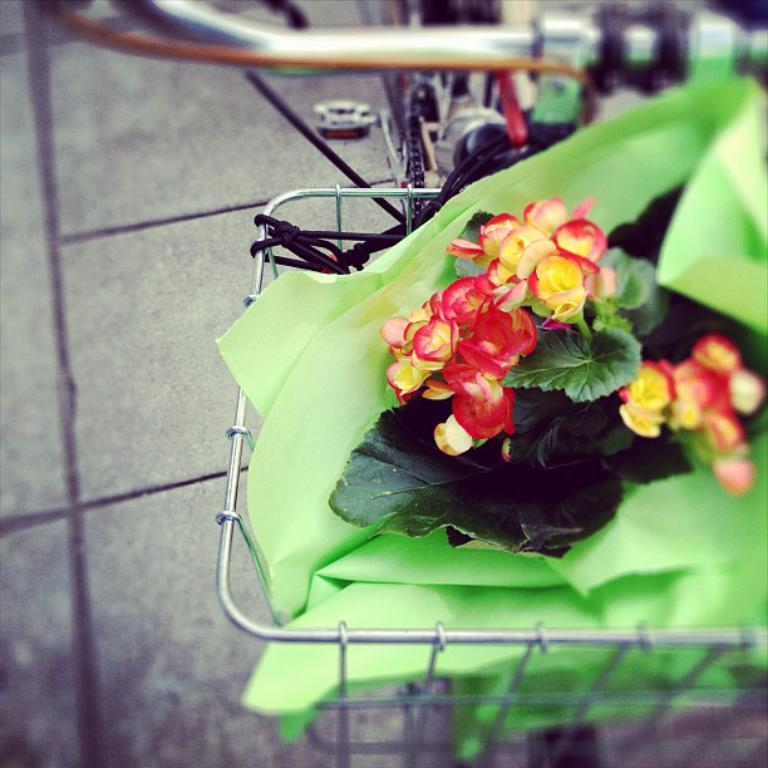What is the main object in the image? There is a bicycle in the image. Where is the bicycle located? The bicycle is on a pathway. What is in the basket on the bicycle? There are flowers, leaves, and papers in the basket. What type of polish is being applied to the leaves in the image? There is no indication in the image that any polish is being applied to the leaves. 